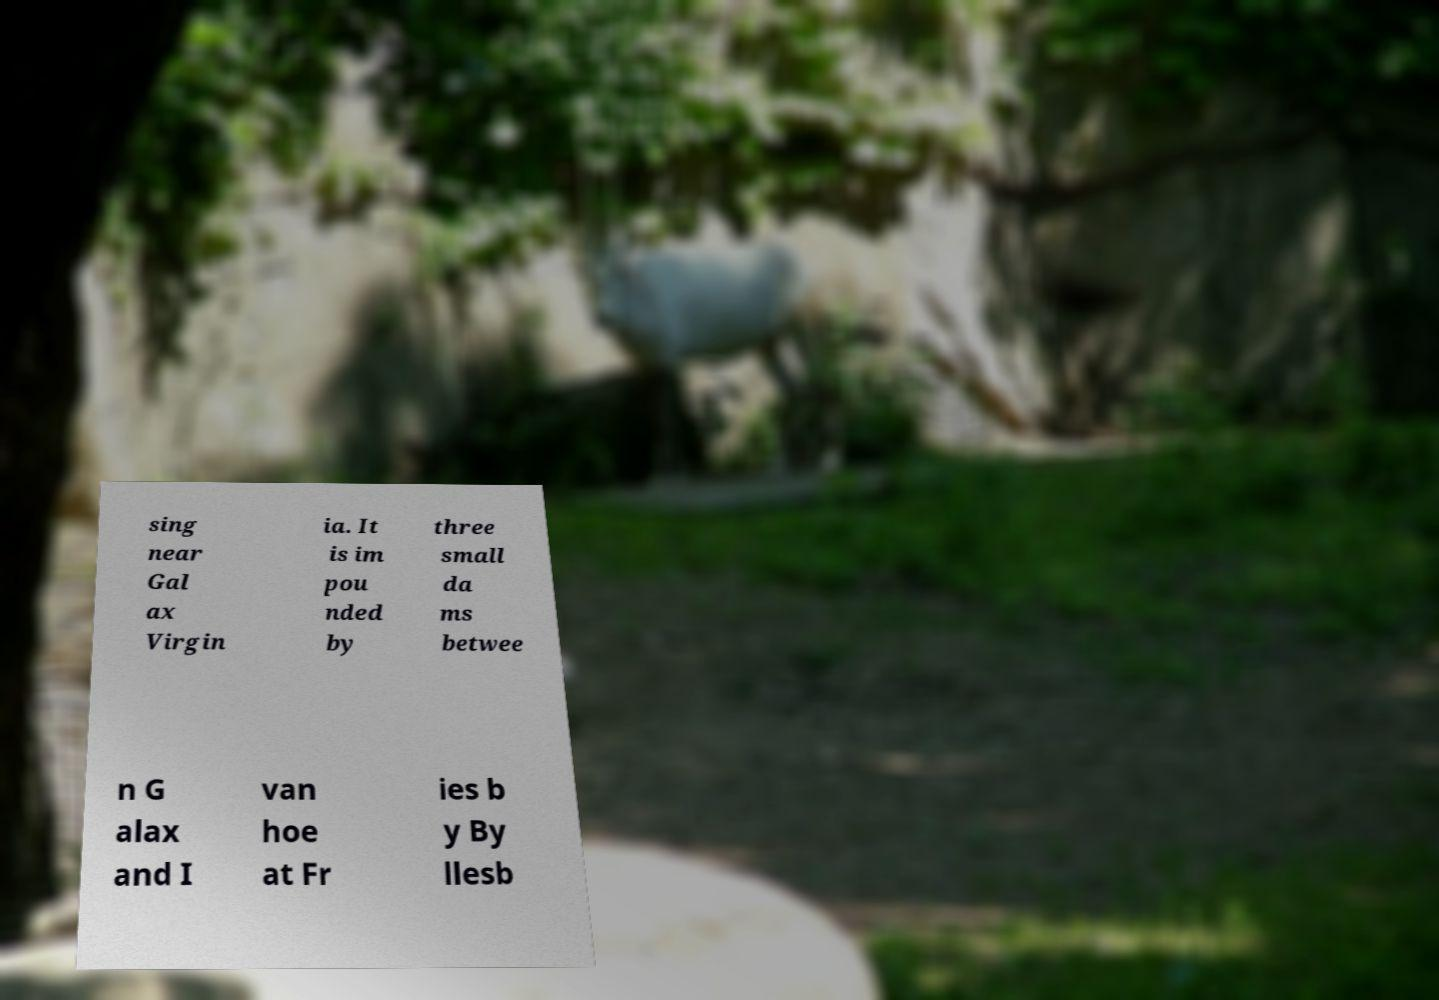There's text embedded in this image that I need extracted. Can you transcribe it verbatim? sing near Gal ax Virgin ia. It is im pou nded by three small da ms betwee n G alax and I van hoe at Fr ies b y By llesb 